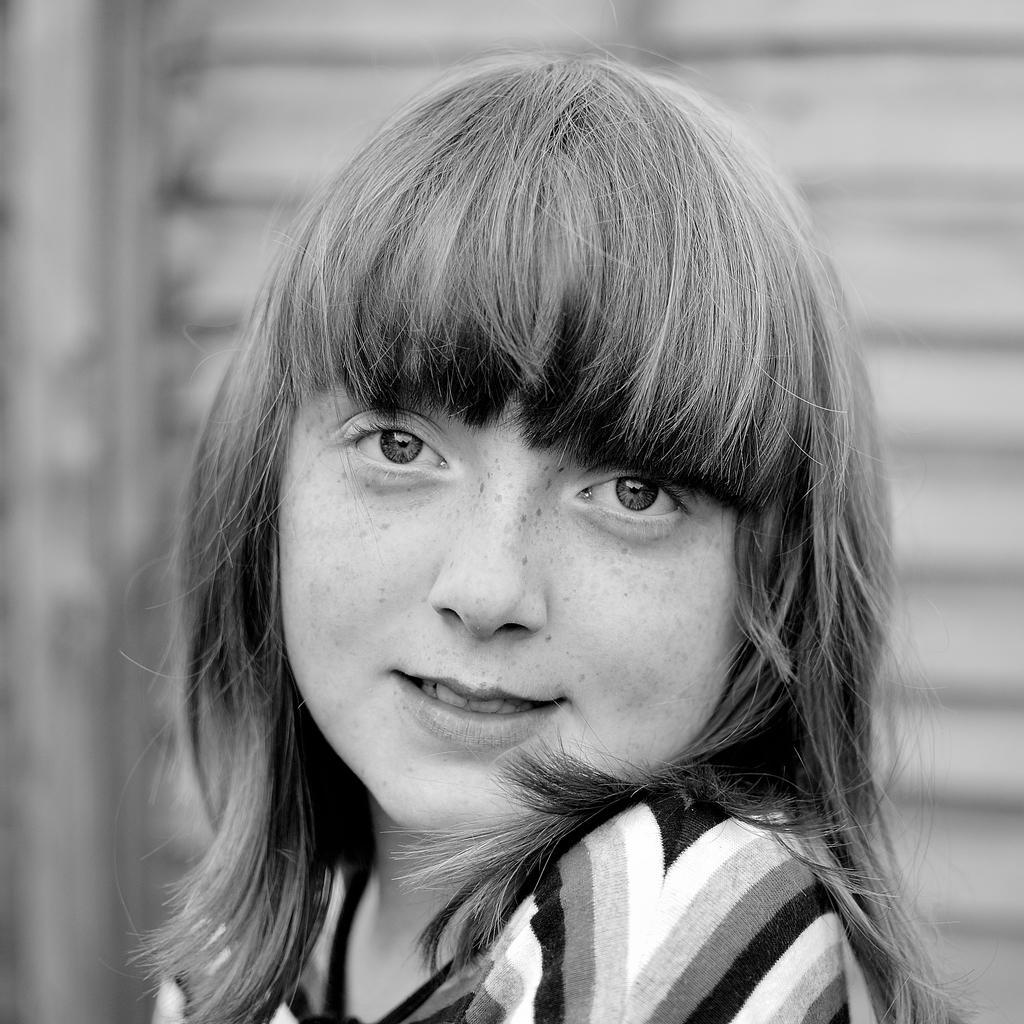How would you summarize this image in a sentence or two? There is a woman smiling. In the background it is blur. 